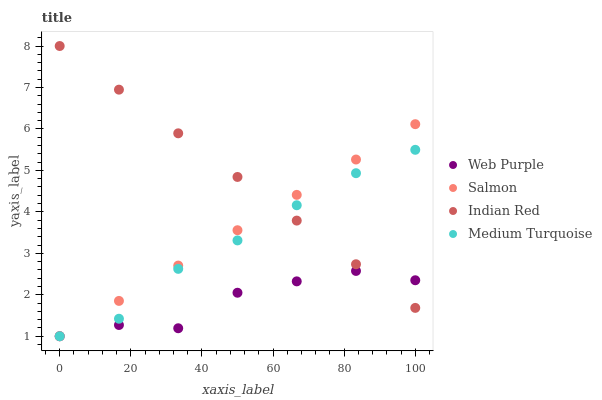Does Web Purple have the minimum area under the curve?
Answer yes or no. Yes. Does Indian Red have the maximum area under the curve?
Answer yes or no. Yes. Does Salmon have the minimum area under the curve?
Answer yes or no. No. Does Salmon have the maximum area under the curve?
Answer yes or no. No. Is Salmon the smoothest?
Answer yes or no. Yes. Is Web Purple the roughest?
Answer yes or no. Yes. Is Medium Turquoise the smoothest?
Answer yes or no. No. Is Medium Turquoise the roughest?
Answer yes or no. No. Does Web Purple have the lowest value?
Answer yes or no. Yes. Does Indian Red have the lowest value?
Answer yes or no. No. Does Indian Red have the highest value?
Answer yes or no. Yes. Does Salmon have the highest value?
Answer yes or no. No. Does Salmon intersect Web Purple?
Answer yes or no. Yes. Is Salmon less than Web Purple?
Answer yes or no. No. Is Salmon greater than Web Purple?
Answer yes or no. No. 